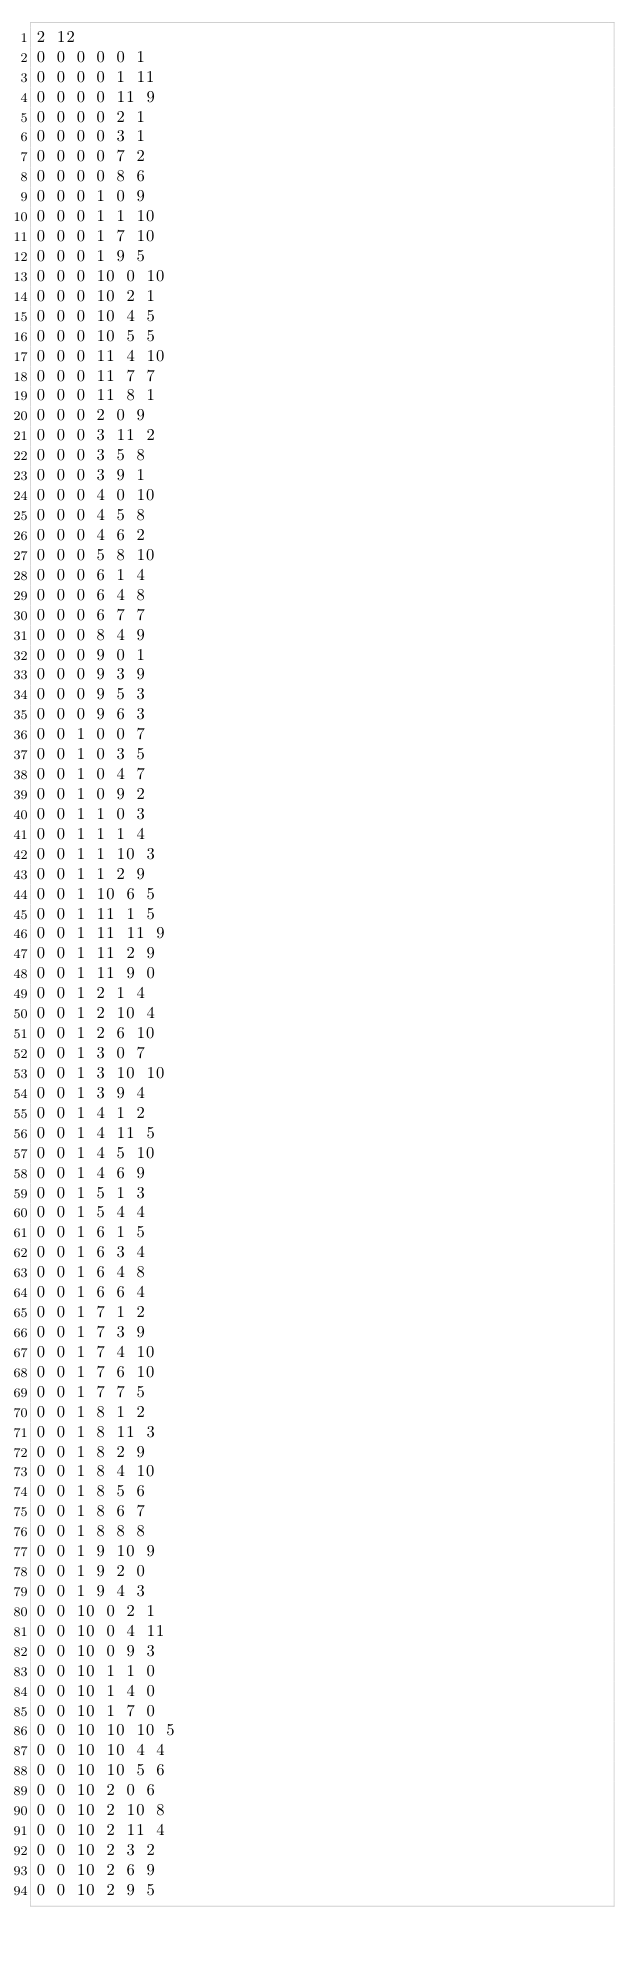Convert code to text. <code><loc_0><loc_0><loc_500><loc_500><_SQL_>2 12
0 0 0 0 0 1
0 0 0 0 1 11
0 0 0 0 11 9
0 0 0 0 2 1
0 0 0 0 3 1
0 0 0 0 7 2
0 0 0 0 8 6
0 0 0 1 0 9
0 0 0 1 1 10
0 0 0 1 7 10
0 0 0 1 9 5
0 0 0 10 0 10
0 0 0 10 2 1
0 0 0 10 4 5
0 0 0 10 5 5
0 0 0 11 4 10
0 0 0 11 7 7
0 0 0 11 8 1
0 0 0 2 0 9
0 0 0 3 11 2
0 0 0 3 5 8
0 0 0 3 9 1
0 0 0 4 0 10
0 0 0 4 5 8
0 0 0 4 6 2
0 0 0 5 8 10
0 0 0 6 1 4
0 0 0 6 4 8
0 0 0 6 7 7
0 0 0 8 4 9
0 0 0 9 0 1
0 0 0 9 3 9
0 0 0 9 5 3
0 0 0 9 6 3
0 0 1 0 0 7
0 0 1 0 3 5
0 0 1 0 4 7
0 0 1 0 9 2
0 0 1 1 0 3
0 0 1 1 1 4
0 0 1 1 10 3
0 0 1 1 2 9
0 0 1 10 6 5
0 0 1 11 1 5
0 0 1 11 11 9
0 0 1 11 2 9
0 0 1 11 9 0
0 0 1 2 1 4
0 0 1 2 10 4
0 0 1 2 6 10
0 0 1 3 0 7
0 0 1 3 10 10
0 0 1 3 9 4
0 0 1 4 1 2
0 0 1 4 11 5
0 0 1 4 5 10
0 0 1 4 6 9
0 0 1 5 1 3
0 0 1 5 4 4
0 0 1 6 1 5
0 0 1 6 3 4
0 0 1 6 4 8
0 0 1 6 6 4
0 0 1 7 1 2
0 0 1 7 3 9
0 0 1 7 4 10
0 0 1 7 6 10
0 0 1 7 7 5
0 0 1 8 1 2
0 0 1 8 11 3
0 0 1 8 2 9
0 0 1 8 4 10
0 0 1 8 5 6
0 0 1 8 6 7
0 0 1 8 8 8
0 0 1 9 10 9
0 0 1 9 2 0
0 0 1 9 4 3
0 0 10 0 2 1
0 0 10 0 4 11
0 0 10 0 9 3
0 0 10 1 1 0
0 0 10 1 4 0
0 0 10 1 7 0
0 0 10 10 10 5
0 0 10 10 4 4
0 0 10 10 5 6
0 0 10 2 0 6
0 0 10 2 10 8
0 0 10 2 11 4
0 0 10 2 3 2
0 0 10 2 6 9
0 0 10 2 9 5</code> 